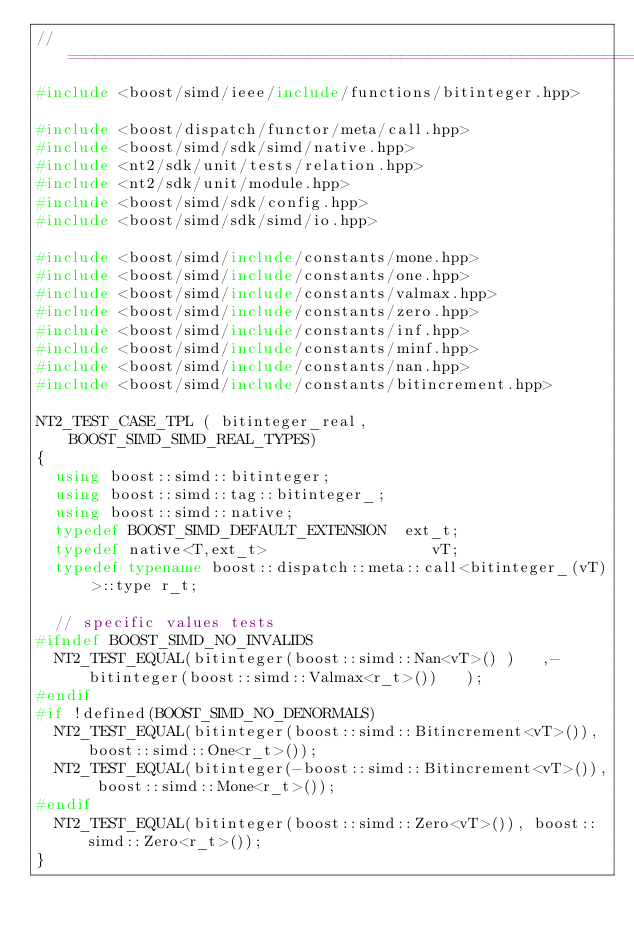<code> <loc_0><loc_0><loc_500><loc_500><_C++_>//==============================================================================
#include <boost/simd/ieee/include/functions/bitinteger.hpp>

#include <boost/dispatch/functor/meta/call.hpp>
#include <boost/simd/sdk/simd/native.hpp>
#include <nt2/sdk/unit/tests/relation.hpp>
#include <nt2/sdk/unit/module.hpp>
#include <boost/simd/sdk/config.hpp>
#include <boost/simd/sdk/simd/io.hpp>

#include <boost/simd/include/constants/mone.hpp>
#include <boost/simd/include/constants/one.hpp>
#include <boost/simd/include/constants/valmax.hpp>
#include <boost/simd/include/constants/zero.hpp>
#include <boost/simd/include/constants/inf.hpp>
#include <boost/simd/include/constants/minf.hpp>
#include <boost/simd/include/constants/nan.hpp>
#include <boost/simd/include/constants/bitincrement.hpp>

NT2_TEST_CASE_TPL ( bitinteger_real,  BOOST_SIMD_SIMD_REAL_TYPES)
{
  using boost::simd::bitinteger;
  using boost::simd::tag::bitinteger_;
  using boost::simd::native;
  typedef BOOST_SIMD_DEFAULT_EXTENSION  ext_t;
  typedef native<T,ext_t>                  vT;
  typedef typename boost::dispatch::meta::call<bitinteger_(vT)>::type r_t;

  // specific values tests
#ifndef BOOST_SIMD_NO_INVALIDS
  NT2_TEST_EQUAL(bitinteger(boost::simd::Nan<vT>() )   ,-bitinteger(boost::simd::Valmax<r_t>())   );
#endif
#if !defined(BOOST_SIMD_NO_DENORMALS)
  NT2_TEST_EQUAL(bitinteger(boost::simd::Bitincrement<vT>()), boost::simd::One<r_t>());
  NT2_TEST_EQUAL(bitinteger(-boost::simd::Bitincrement<vT>()), boost::simd::Mone<r_t>());
#endif
  NT2_TEST_EQUAL(bitinteger(boost::simd::Zero<vT>()), boost::simd::Zero<r_t>());
}
</code> 